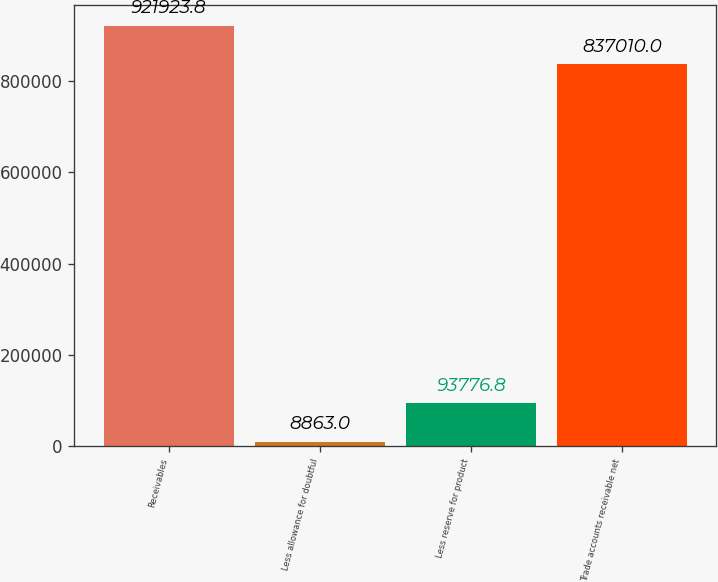<chart> <loc_0><loc_0><loc_500><loc_500><bar_chart><fcel>Receivables<fcel>Less allowance for doubtful<fcel>Less reserve for product<fcel>Trade accounts receivable net<nl><fcel>921924<fcel>8863<fcel>93776.8<fcel>837010<nl></chart> 